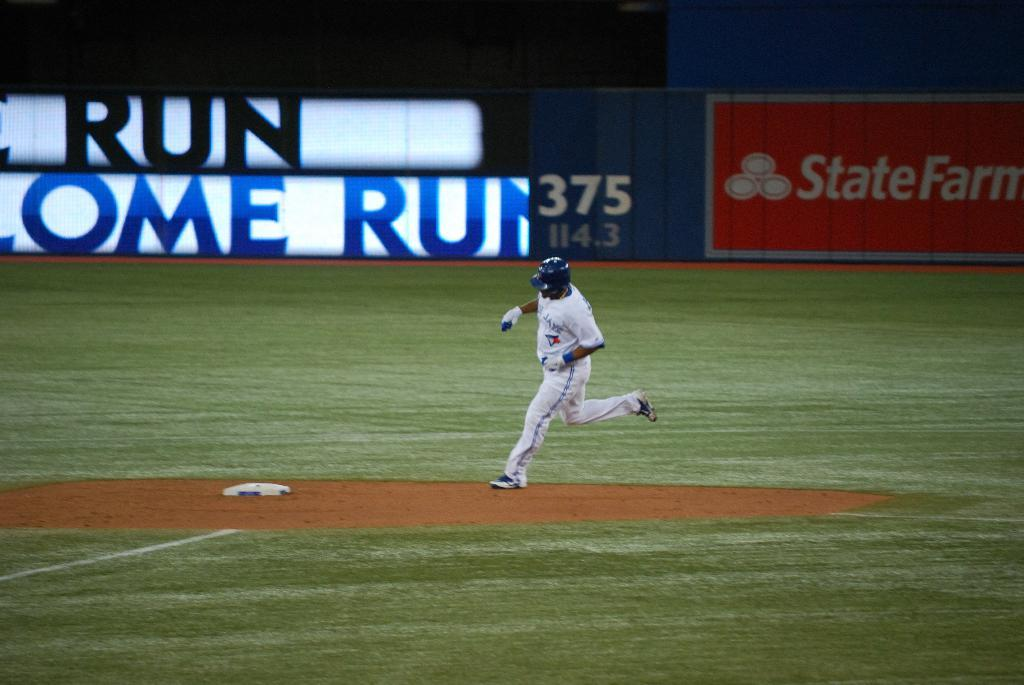<image>
Provide a brief description of the given image. A baseball player runs past a backdrop that says run. 